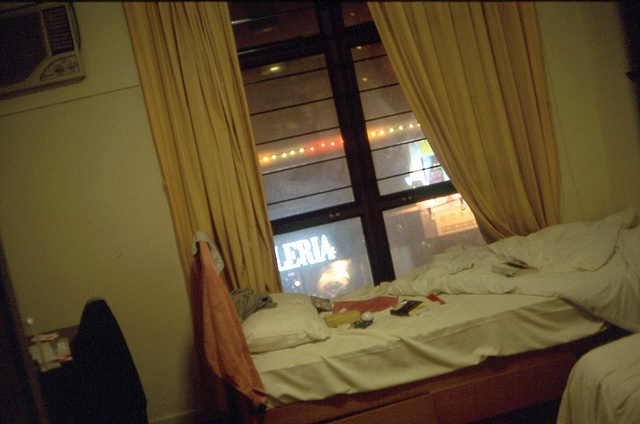Describe the objects in this image and their specific colors. I can see bed in black, olive, and maroon tones, chair in black and darkgreen tones, bed in black and olive tones, book in black and olive tones, and book in black, olive, and maroon tones in this image. 